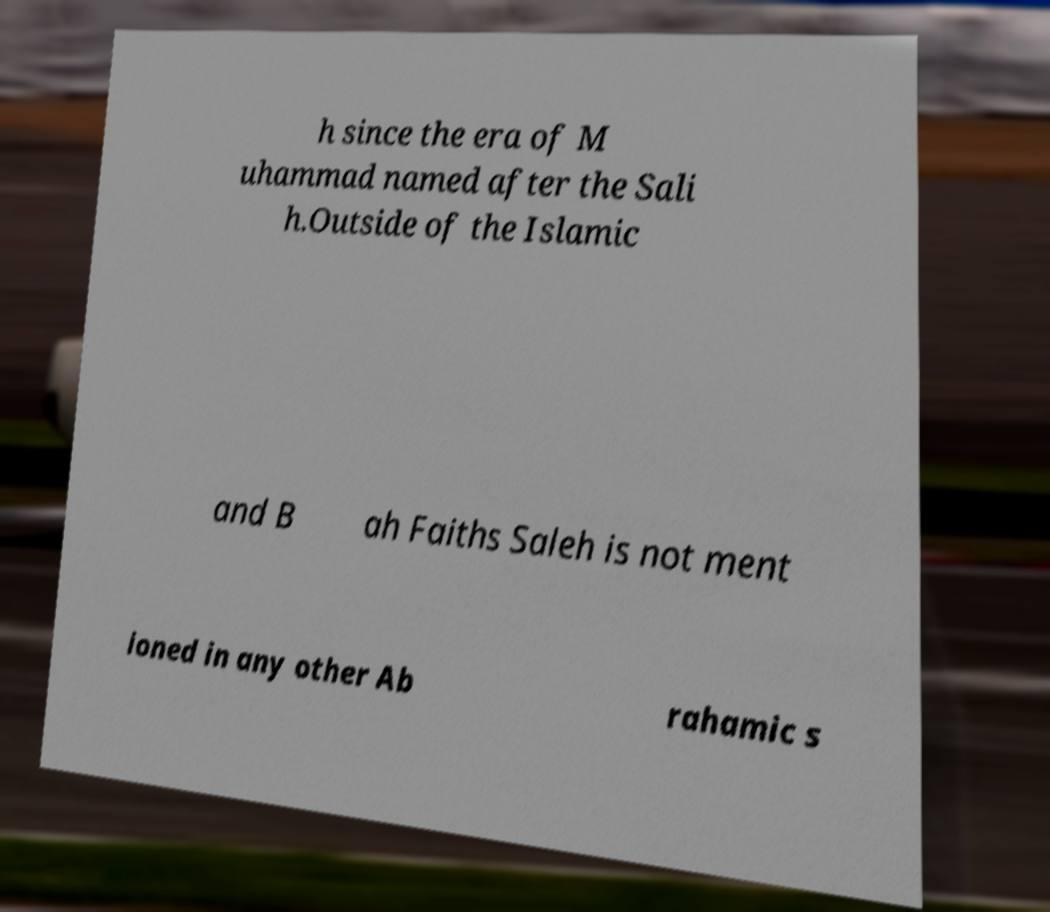There's text embedded in this image that I need extracted. Can you transcribe it verbatim? h since the era of M uhammad named after the Sali h.Outside of the Islamic and B ah Faiths Saleh is not ment ioned in any other Ab rahamic s 